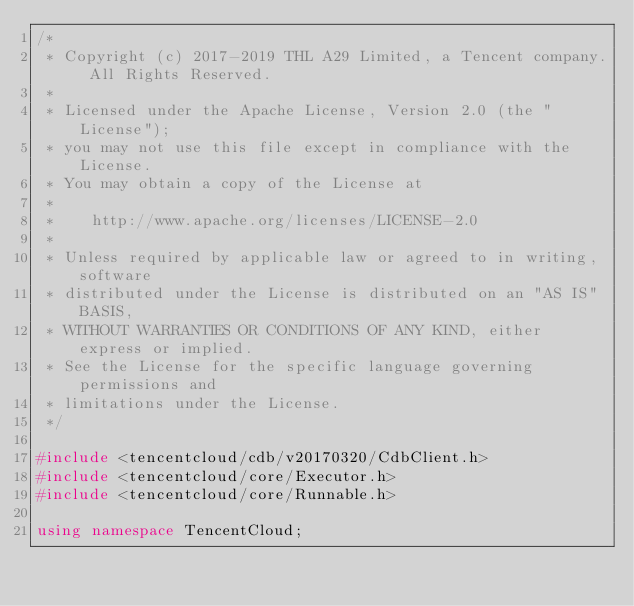Convert code to text. <code><loc_0><loc_0><loc_500><loc_500><_C++_>/*
 * Copyright (c) 2017-2019 THL A29 Limited, a Tencent company. All Rights Reserved.
 *
 * Licensed under the Apache License, Version 2.0 (the "License");
 * you may not use this file except in compliance with the License.
 * You may obtain a copy of the License at
 *
 *    http://www.apache.org/licenses/LICENSE-2.0
 *
 * Unless required by applicable law or agreed to in writing, software
 * distributed under the License is distributed on an "AS IS" BASIS,
 * WITHOUT WARRANTIES OR CONDITIONS OF ANY KIND, either express or implied.
 * See the License for the specific language governing permissions and
 * limitations under the License.
 */

#include <tencentcloud/cdb/v20170320/CdbClient.h>
#include <tencentcloud/core/Executor.h>
#include <tencentcloud/core/Runnable.h>

using namespace TencentCloud;</code> 